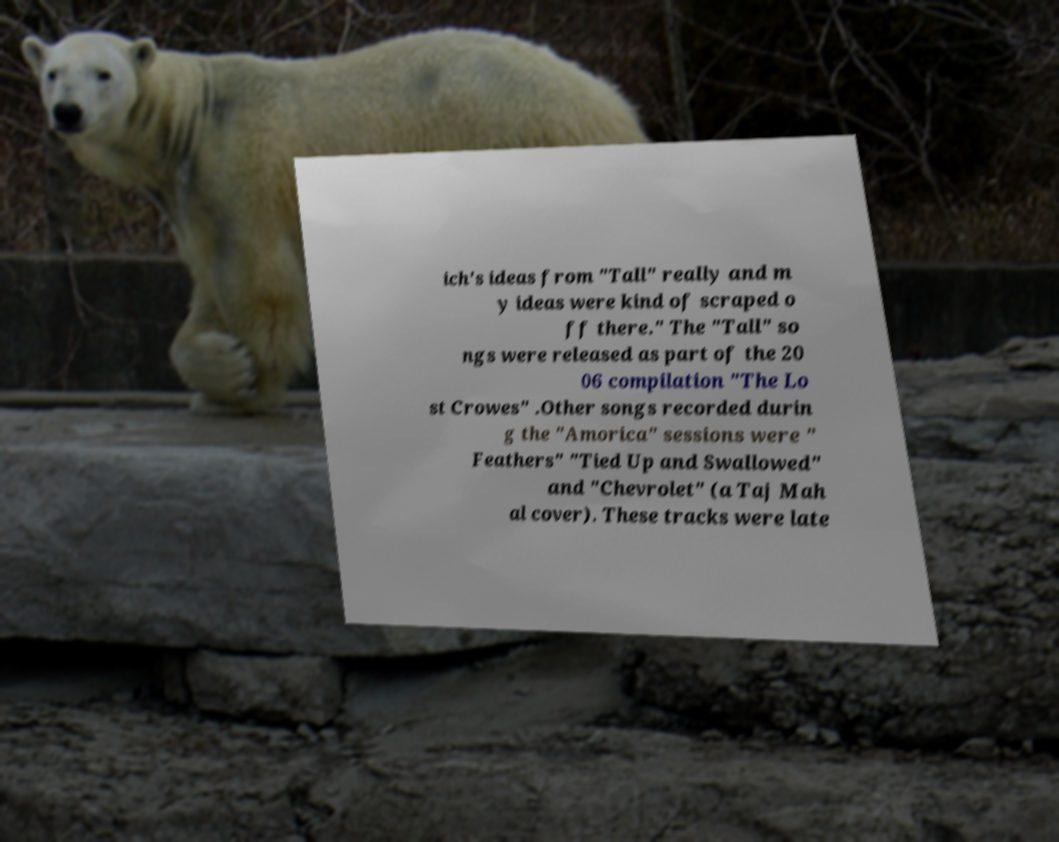What messages or text are displayed in this image? I need them in a readable, typed format. ich's ideas from "Tall" really and m y ideas were kind of scraped o ff there." The "Tall" so ngs were released as part of the 20 06 compilation "The Lo st Crowes" .Other songs recorded durin g the "Amorica" sessions were " Feathers" "Tied Up and Swallowed" and "Chevrolet" (a Taj Mah al cover). These tracks were late 